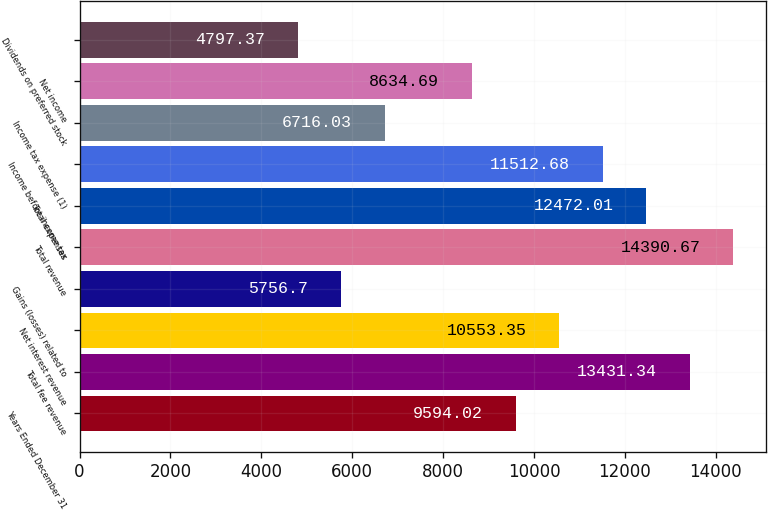Convert chart to OTSL. <chart><loc_0><loc_0><loc_500><loc_500><bar_chart><fcel>Years Ended December 31<fcel>Total fee revenue<fcel>Net interest revenue<fcel>Gains (losses) related to<fcel>Total revenue<fcel>Total expenses<fcel>Income before income tax<fcel>Income tax expense (1)<fcel>Net income<fcel>Dividends on preferred stock<nl><fcel>9594.02<fcel>13431.3<fcel>10553.4<fcel>5756.7<fcel>14390.7<fcel>12472<fcel>11512.7<fcel>6716.03<fcel>8634.69<fcel>4797.37<nl></chart> 